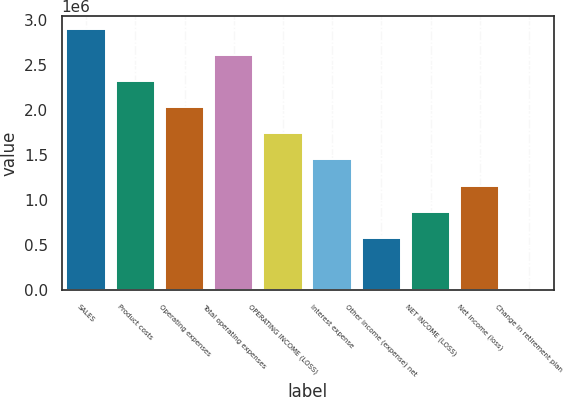Convert chart. <chart><loc_0><loc_0><loc_500><loc_500><bar_chart><fcel>SALES<fcel>Product costs<fcel>Operating expenses<fcel>Total operating expenses<fcel>OPERATING INCOME (LOSS)<fcel>Interest expense<fcel>Other income (expense) net<fcel>NET INCOME (LOSS)<fcel>Net income (loss)<fcel>Change in retirement plan<nl><fcel>2.89823e+06<fcel>2.3191e+06<fcel>2.02954e+06<fcel>2.60867e+06<fcel>1.73997e+06<fcel>1.45041e+06<fcel>581718<fcel>871282<fcel>1.16085e+06<fcel>2589<nl></chart> 